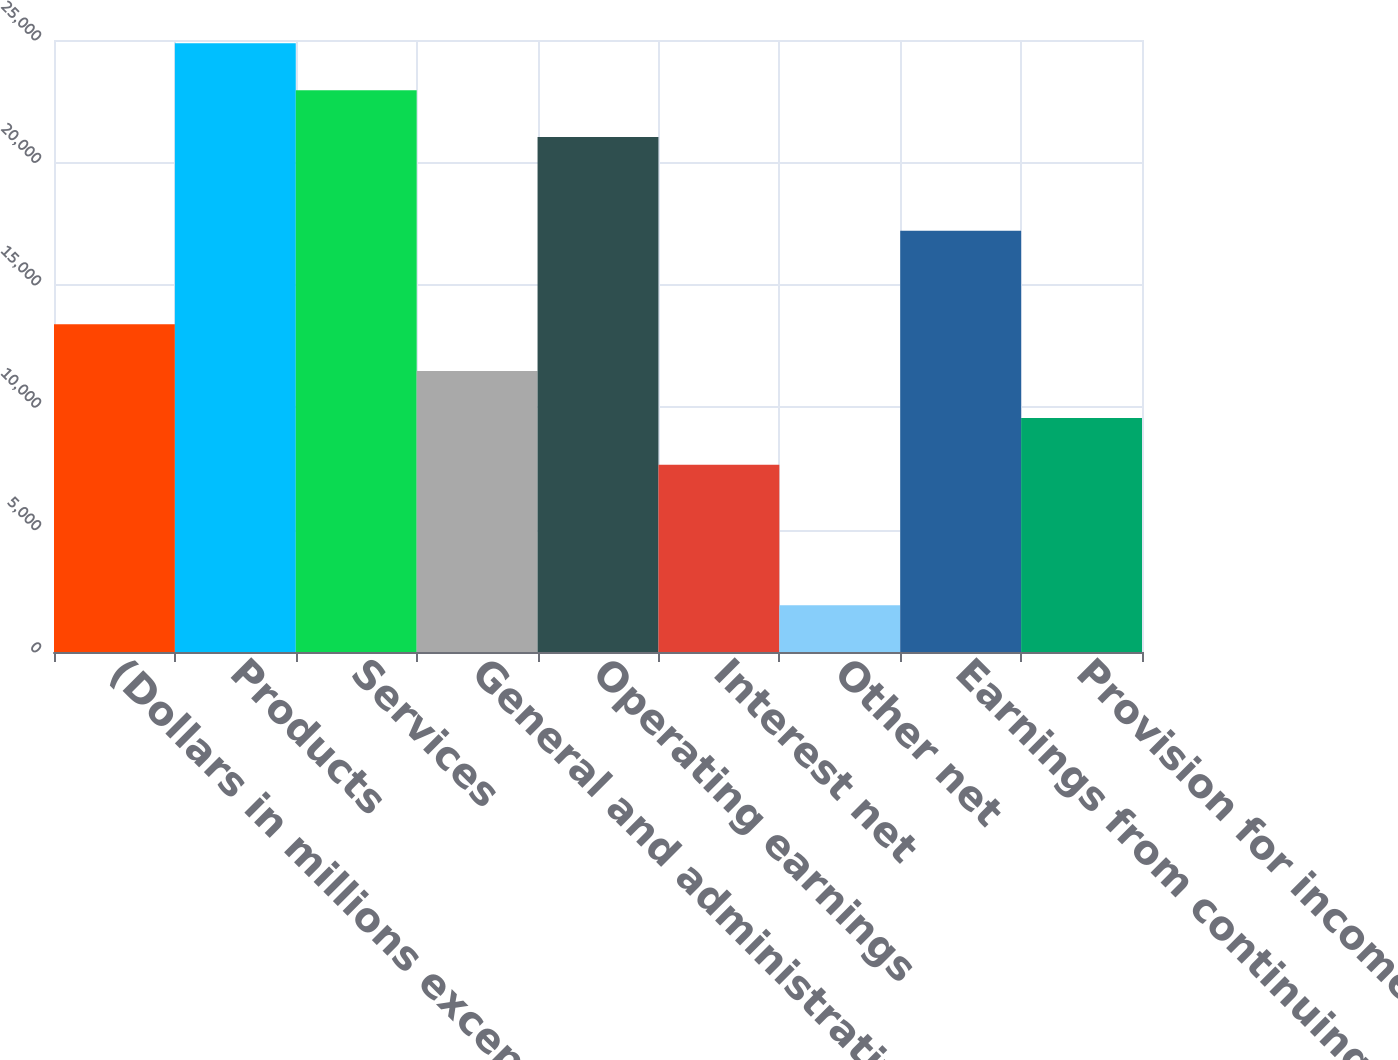<chart> <loc_0><loc_0><loc_500><loc_500><bar_chart><fcel>(Dollars in millions except<fcel>Products<fcel>Services<fcel>General and administrative<fcel>Operating earnings<fcel>Interest net<fcel>Other net<fcel>Earnings from continuing<fcel>Provision for income taxes net<nl><fcel>13387.5<fcel>24862.5<fcel>22950<fcel>11475<fcel>21037.5<fcel>7650.02<fcel>1912.52<fcel>17212.5<fcel>9562.52<nl></chart> 